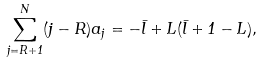Convert formula to latex. <formula><loc_0><loc_0><loc_500><loc_500>\sum _ { j = R + 1 } ^ { N } ( j - R ) a _ { j } = - \bar { l } + L ( \bar { l } + 1 - L ) ,</formula> 